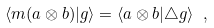Convert formula to latex. <formula><loc_0><loc_0><loc_500><loc_500>\langle m ( a \otimes b ) | g \rangle = \langle a \otimes b | \triangle g \rangle \ ,</formula> 